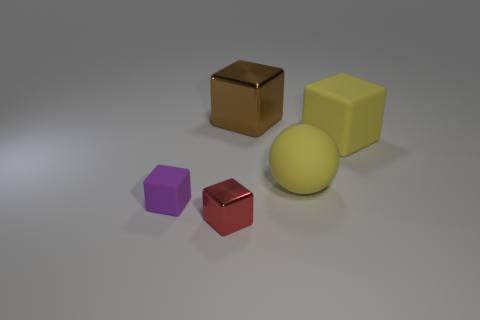Subtract 1 blocks. How many blocks are left? 3 Add 5 shiny objects. How many objects exist? 10 Subtract all blocks. How many objects are left? 1 Subtract 0 cyan balls. How many objects are left? 5 Subtract all small red things. Subtract all purple matte cubes. How many objects are left? 3 Add 4 large metal cubes. How many large metal cubes are left? 5 Add 3 large rubber objects. How many large rubber objects exist? 5 